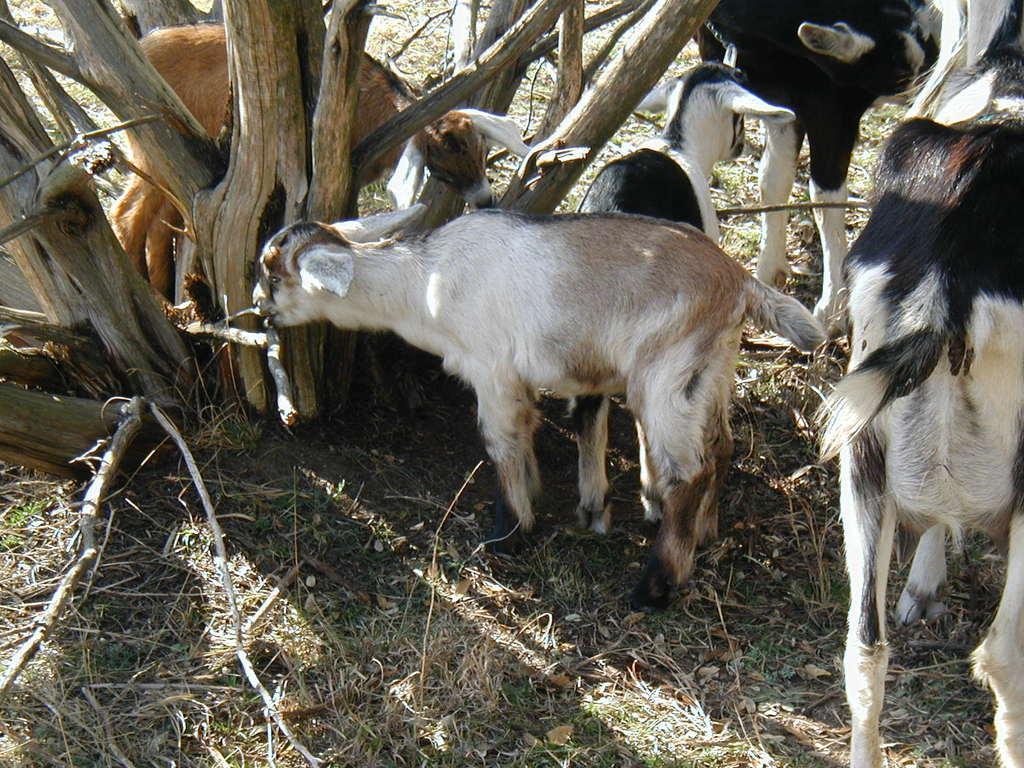In one or two sentences, can you explain what this image depicts? As we can see in the image there are sheeps, dry grass and tree stem. 